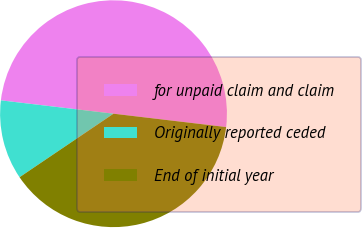Convert chart. <chart><loc_0><loc_0><loc_500><loc_500><pie_chart><fcel>for unpaid claim and claim<fcel>Originally reported ceded<fcel>End of initial year<nl><fcel>50.0%<fcel>11.34%<fcel>38.66%<nl></chart> 